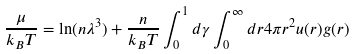<formula> <loc_0><loc_0><loc_500><loc_500>\frac { \mu } { k _ { B } T } = \ln ( n \lambda ^ { 3 } ) + \frac { n } { k _ { B } T } \int _ { 0 } ^ { 1 } d \gamma \int _ { 0 } ^ { \infty } d r 4 \pi r ^ { 2 } u ( r ) g ( r )</formula> 